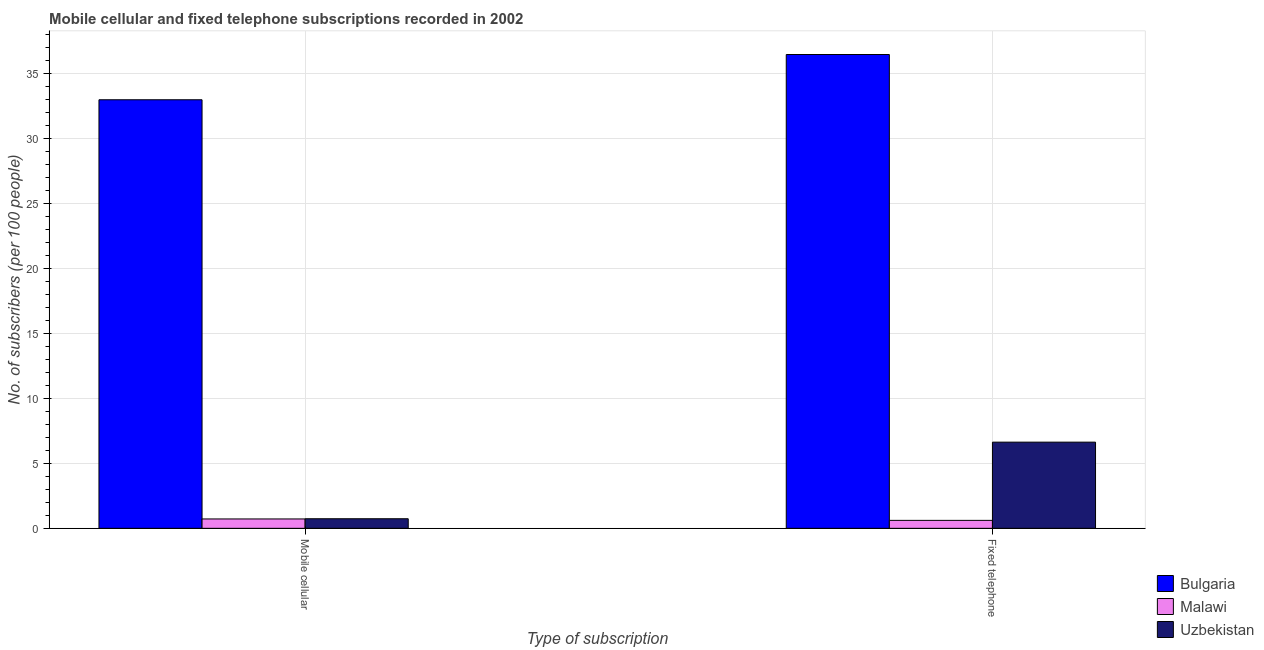How many different coloured bars are there?
Ensure brevity in your answer.  3. Are the number of bars per tick equal to the number of legend labels?
Give a very brief answer. Yes. How many bars are there on the 1st tick from the left?
Give a very brief answer. 3. How many bars are there on the 1st tick from the right?
Make the answer very short. 3. What is the label of the 1st group of bars from the left?
Your answer should be very brief. Mobile cellular. What is the number of mobile cellular subscribers in Malawi?
Provide a succinct answer. 0.72. Across all countries, what is the maximum number of mobile cellular subscribers?
Provide a succinct answer. 33. Across all countries, what is the minimum number of fixed telephone subscribers?
Ensure brevity in your answer.  0.61. In which country was the number of mobile cellular subscribers minimum?
Offer a terse response. Malawi. What is the total number of fixed telephone subscribers in the graph?
Provide a short and direct response. 43.74. What is the difference between the number of mobile cellular subscribers in Bulgaria and that in Malawi?
Give a very brief answer. 32.28. What is the difference between the number of mobile cellular subscribers in Uzbekistan and the number of fixed telephone subscribers in Bulgaria?
Provide a succinct answer. -35.75. What is the average number of mobile cellular subscribers per country?
Offer a terse response. 11.49. What is the difference between the number of mobile cellular subscribers and number of fixed telephone subscribers in Bulgaria?
Your answer should be compact. -3.48. What is the ratio of the number of fixed telephone subscribers in Bulgaria to that in Malawi?
Keep it short and to the point. 59.53. Is the number of fixed telephone subscribers in Bulgaria less than that in Uzbekistan?
Make the answer very short. No. What does the 3rd bar from the left in Mobile cellular represents?
Your answer should be very brief. Uzbekistan. Does the graph contain any zero values?
Provide a succinct answer. No. Where does the legend appear in the graph?
Ensure brevity in your answer.  Bottom right. How many legend labels are there?
Offer a terse response. 3. What is the title of the graph?
Provide a succinct answer. Mobile cellular and fixed telephone subscriptions recorded in 2002. Does "Azerbaijan" appear as one of the legend labels in the graph?
Make the answer very short. No. What is the label or title of the X-axis?
Provide a short and direct response. Type of subscription. What is the label or title of the Y-axis?
Keep it short and to the point. No. of subscribers (per 100 people). What is the No. of subscribers (per 100 people) in Bulgaria in Mobile cellular?
Keep it short and to the point. 33. What is the No. of subscribers (per 100 people) of Malawi in Mobile cellular?
Make the answer very short. 0.72. What is the No. of subscribers (per 100 people) of Uzbekistan in Mobile cellular?
Provide a succinct answer. 0.74. What is the No. of subscribers (per 100 people) of Bulgaria in Fixed telephone?
Offer a very short reply. 36.49. What is the No. of subscribers (per 100 people) in Malawi in Fixed telephone?
Offer a very short reply. 0.61. What is the No. of subscribers (per 100 people) in Uzbekistan in Fixed telephone?
Your response must be concise. 6.64. Across all Type of subscription, what is the maximum No. of subscribers (per 100 people) of Bulgaria?
Give a very brief answer. 36.49. Across all Type of subscription, what is the maximum No. of subscribers (per 100 people) in Malawi?
Offer a terse response. 0.72. Across all Type of subscription, what is the maximum No. of subscribers (per 100 people) in Uzbekistan?
Offer a very short reply. 6.64. Across all Type of subscription, what is the minimum No. of subscribers (per 100 people) of Bulgaria?
Give a very brief answer. 33. Across all Type of subscription, what is the minimum No. of subscribers (per 100 people) in Malawi?
Your answer should be very brief. 0.61. Across all Type of subscription, what is the minimum No. of subscribers (per 100 people) of Uzbekistan?
Provide a succinct answer. 0.74. What is the total No. of subscribers (per 100 people) in Bulgaria in the graph?
Your answer should be very brief. 69.49. What is the total No. of subscribers (per 100 people) in Malawi in the graph?
Provide a succinct answer. 1.33. What is the total No. of subscribers (per 100 people) in Uzbekistan in the graph?
Make the answer very short. 7.37. What is the difference between the No. of subscribers (per 100 people) in Bulgaria in Mobile cellular and that in Fixed telephone?
Provide a short and direct response. -3.48. What is the difference between the No. of subscribers (per 100 people) of Malawi in Mobile cellular and that in Fixed telephone?
Keep it short and to the point. 0.11. What is the difference between the No. of subscribers (per 100 people) in Uzbekistan in Mobile cellular and that in Fixed telephone?
Ensure brevity in your answer.  -5.9. What is the difference between the No. of subscribers (per 100 people) of Bulgaria in Mobile cellular and the No. of subscribers (per 100 people) of Malawi in Fixed telephone?
Your answer should be very brief. 32.39. What is the difference between the No. of subscribers (per 100 people) in Bulgaria in Mobile cellular and the No. of subscribers (per 100 people) in Uzbekistan in Fixed telephone?
Your answer should be compact. 26.37. What is the difference between the No. of subscribers (per 100 people) in Malawi in Mobile cellular and the No. of subscribers (per 100 people) in Uzbekistan in Fixed telephone?
Your answer should be very brief. -5.91. What is the average No. of subscribers (per 100 people) of Bulgaria per Type of subscription?
Offer a terse response. 34.75. What is the average No. of subscribers (per 100 people) of Malawi per Type of subscription?
Keep it short and to the point. 0.67. What is the average No. of subscribers (per 100 people) in Uzbekistan per Type of subscription?
Provide a short and direct response. 3.69. What is the difference between the No. of subscribers (per 100 people) of Bulgaria and No. of subscribers (per 100 people) of Malawi in Mobile cellular?
Your response must be concise. 32.28. What is the difference between the No. of subscribers (per 100 people) of Bulgaria and No. of subscribers (per 100 people) of Uzbekistan in Mobile cellular?
Your answer should be compact. 32.27. What is the difference between the No. of subscribers (per 100 people) of Malawi and No. of subscribers (per 100 people) of Uzbekistan in Mobile cellular?
Keep it short and to the point. -0.02. What is the difference between the No. of subscribers (per 100 people) of Bulgaria and No. of subscribers (per 100 people) of Malawi in Fixed telephone?
Keep it short and to the point. 35.88. What is the difference between the No. of subscribers (per 100 people) in Bulgaria and No. of subscribers (per 100 people) in Uzbekistan in Fixed telephone?
Your answer should be very brief. 29.85. What is the difference between the No. of subscribers (per 100 people) in Malawi and No. of subscribers (per 100 people) in Uzbekistan in Fixed telephone?
Keep it short and to the point. -6.02. What is the ratio of the No. of subscribers (per 100 people) of Bulgaria in Mobile cellular to that in Fixed telephone?
Give a very brief answer. 0.9. What is the ratio of the No. of subscribers (per 100 people) in Malawi in Mobile cellular to that in Fixed telephone?
Give a very brief answer. 1.18. What is the ratio of the No. of subscribers (per 100 people) in Uzbekistan in Mobile cellular to that in Fixed telephone?
Your answer should be compact. 0.11. What is the difference between the highest and the second highest No. of subscribers (per 100 people) of Bulgaria?
Your answer should be very brief. 3.48. What is the difference between the highest and the second highest No. of subscribers (per 100 people) of Malawi?
Make the answer very short. 0.11. What is the difference between the highest and the second highest No. of subscribers (per 100 people) of Uzbekistan?
Keep it short and to the point. 5.9. What is the difference between the highest and the lowest No. of subscribers (per 100 people) of Bulgaria?
Your answer should be compact. 3.48. What is the difference between the highest and the lowest No. of subscribers (per 100 people) of Malawi?
Offer a very short reply. 0.11. What is the difference between the highest and the lowest No. of subscribers (per 100 people) in Uzbekistan?
Keep it short and to the point. 5.9. 